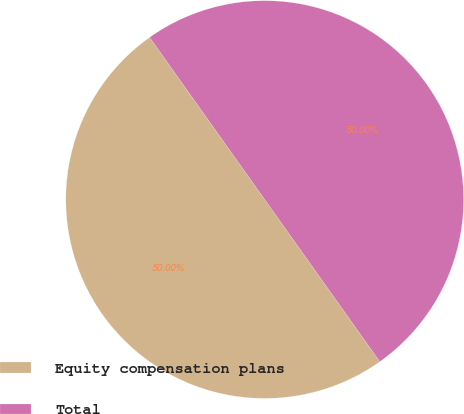Convert chart. <chart><loc_0><loc_0><loc_500><loc_500><pie_chart><fcel>Equity compensation plans<fcel>Total<nl><fcel>50.0%<fcel>50.0%<nl></chart> 